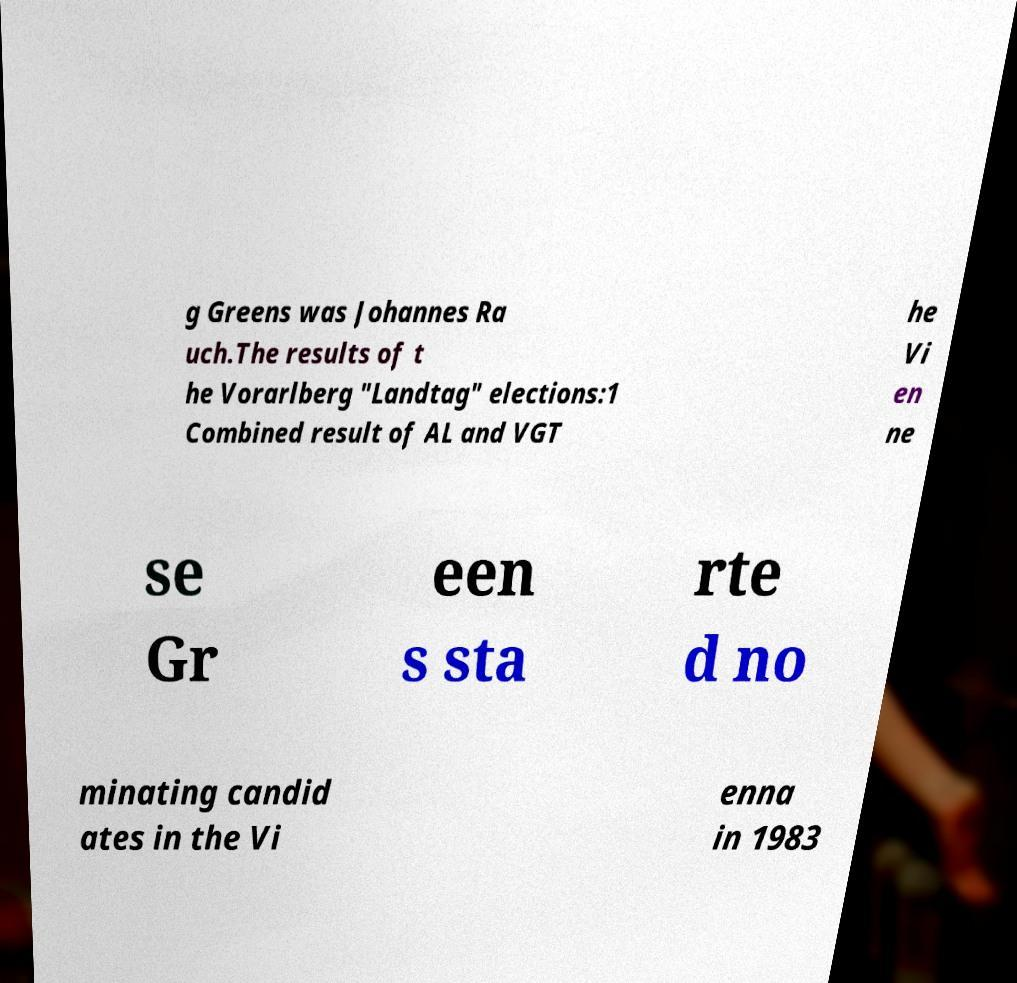Could you assist in decoding the text presented in this image and type it out clearly? g Greens was Johannes Ra uch.The results of t he Vorarlberg "Landtag" elections:1 Combined result of AL and VGT he Vi en ne se Gr een s sta rte d no minating candid ates in the Vi enna in 1983 